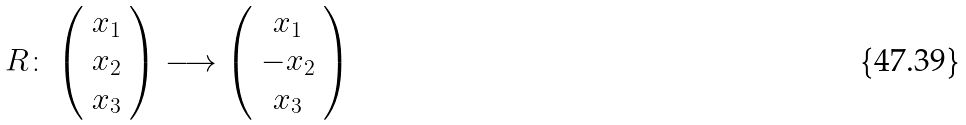<formula> <loc_0><loc_0><loc_500><loc_500>R \colon \left ( \begin{array} { c } x _ { 1 } \\ x _ { 2 } \\ x _ { 3 } \\ \end{array} \right ) \longrightarrow \left ( \begin{array} { c } x _ { 1 } \\ - x _ { 2 } \\ x _ { 3 } \\ \end{array} \right )</formula> 